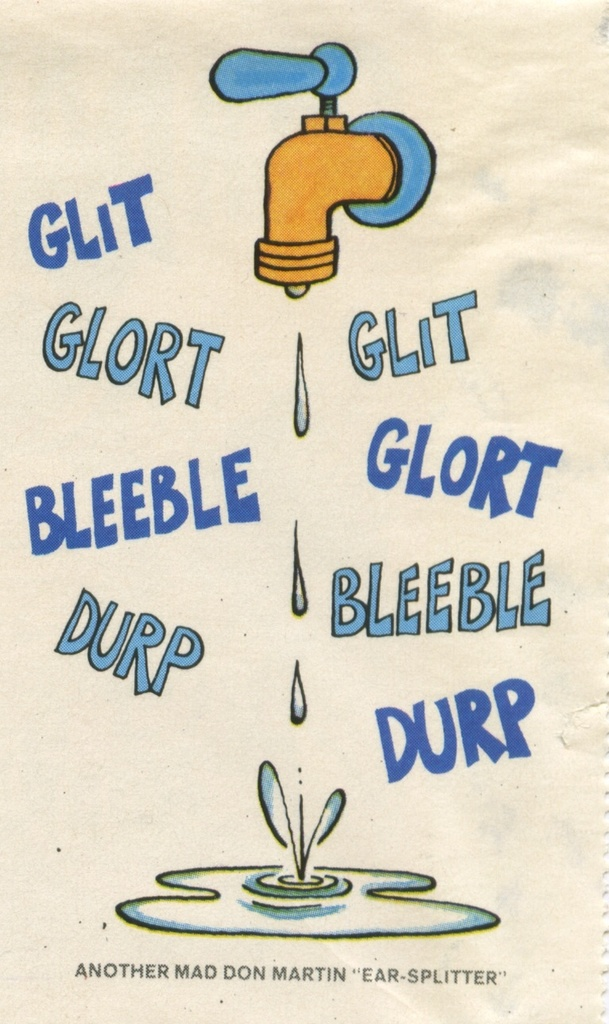What do you see happening in this image? The image displays a cartoon-style drawing of a blue faucet with water dripping from it, landing into a growing puddle below. The faucet and the water droplets are surrounded by various colorful words like 'glit', 'glort', 'bleeble', and 'durp', representing an imaginative take on the sounds of the dripping water. The phrase 'Another Mad Don Martin 'Ear-Splitter'' humorously suggests these sounds are exaggeratedly loud. This playful and creative visual is likely a piece of comic art, aimed at humorously capturing the mundane yet slightly annoying experience of a persistently dripping tap. 